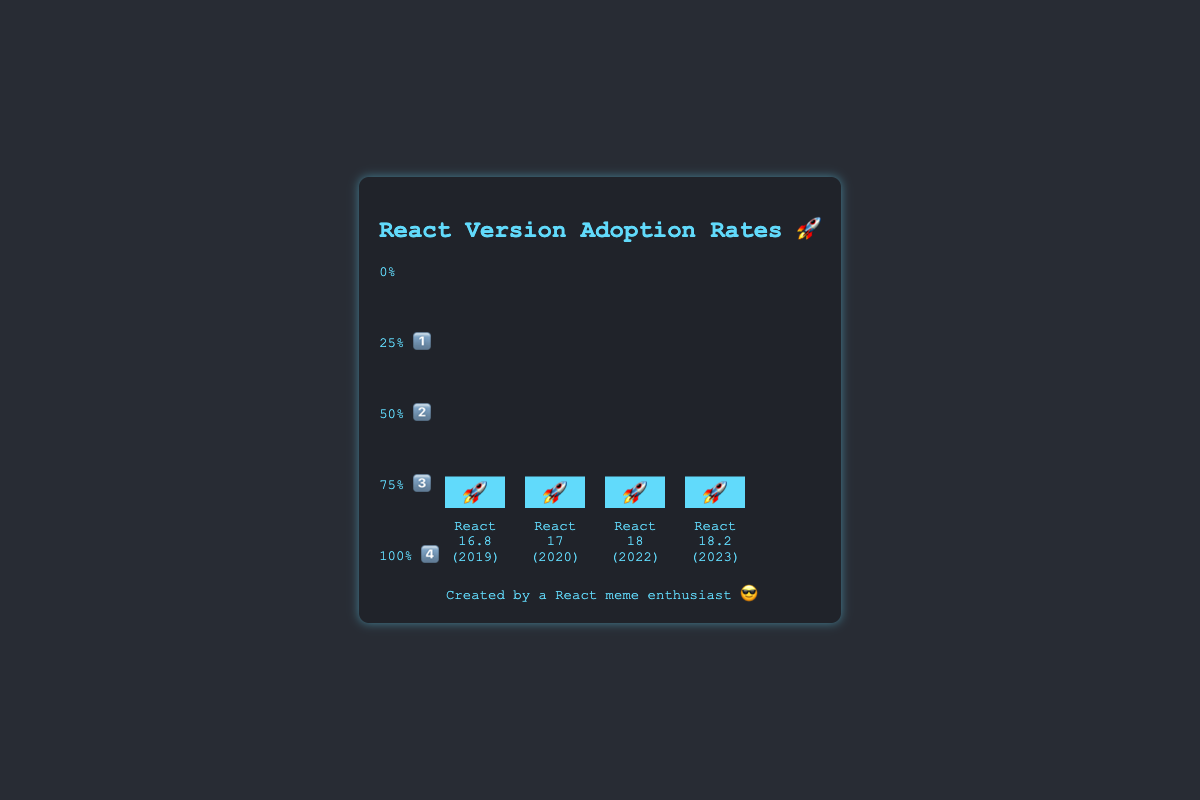What's the title of the chart? The title of the chart is the text at the top-center of the visual. It is “React Version Adoption Rates 🚀”.
Answer: React Version Adoption Rates 🚀 Which React version has the highest adoption rate? The bar with the highest height indicates the React version with the highest adoption rate. The bar for React 16.8 has the highest height, which corresponds to 75%.
Answer: React 16.8 What year does the React version with the lowest adoption rate belong to? The bar with the lowest height corresponding to React 18.2 has an adoption rate of 30%. This version is labeled with the year 2023.
Answer: 2023 How much higher is the adoption rate of React 16.8 compared to React 18? The adoption rate of React 16.8 is 75%, and the adoption rate of React 18 is 45%. Subtracting the two values: 75% - 45% = 30%.
Answer: 30% Rank the React versions by their adoption rates in descending order. By comparing the heights of the bars, the adoption rates in descending order are: React 16.8 (75%), React 17 (60%), React 18 (45%), React 18.2 (30%).
Answer: React 16.8, React 17, React 18, React 18.2 What is the percentage range indicated by the emoji 🎨 on the y-axis? On the y-axis, 4️⃣ corresponds to 100%, 3️⃣ to 75%, 2️⃣ to 50%, and 1️⃣ to 25%. There is no emoji 🎨 specifically shown in the given data. Perhaps there is an error or confusion in the emoji used, please double-check.
Answer: Emoji not present in data What is the average adoption rate of all React versions shown? The adoption rates given are 75%, 60%, 45%, and 30%. Adding these: 75 + 60 + 45 + 30 = 210. Dividing by 4 (the number of versions) gives: 210 / 4 = 52.5%.
Answer: 52.5% For which year is the adoption rate growth the highest from the previous year? Comparing yearly differences, from 2019 to 2020, the rate falls (75% to 60%). From 2020 to 2022, it falls again (60% to 45%). From 2022 to 2023, it again falls (45% to 30%). There is no year where the rate grows, only falls.
Answer: None What is the collective adoption percentage of React 16.8 and React 17? Adding the adoption rates of React 16.8 (75%) and React 17 (60%): 75 + 60 = 135%.
Answer: 135% 